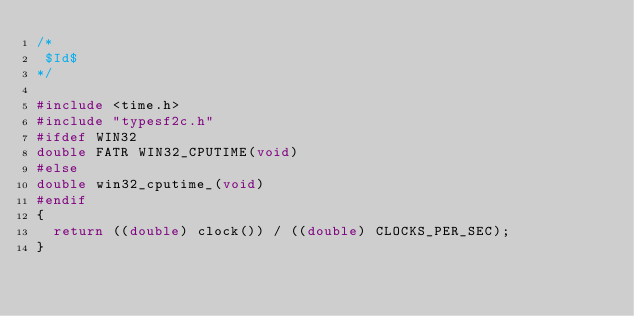Convert code to text. <code><loc_0><loc_0><loc_500><loc_500><_C_>/*
 $Id$
*/

#include <time.h>
#include "typesf2c.h"
#ifdef WIN32
double FATR WIN32_CPUTIME(void)
#else
double win32_cputime_(void)
#endif
{
  return ((double) clock()) / ((double) CLOCKS_PER_SEC);
}
</code> 